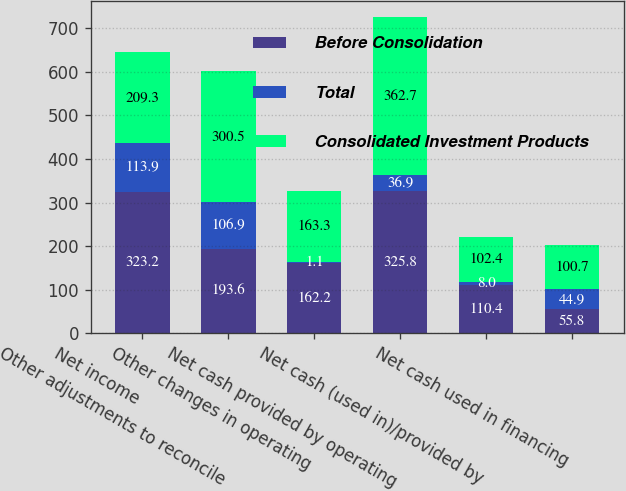Convert chart to OTSL. <chart><loc_0><loc_0><loc_500><loc_500><stacked_bar_chart><ecel><fcel>Net income<fcel>Other adjustments to reconcile<fcel>Other changes in operating<fcel>Net cash provided by operating<fcel>Net cash (used in)/provided by<fcel>Net cash used in financing<nl><fcel>Before Consolidation<fcel>323.2<fcel>193.6<fcel>162.2<fcel>325.8<fcel>110.4<fcel>55.8<nl><fcel>Total<fcel>113.9<fcel>106.9<fcel>1.1<fcel>36.9<fcel>8<fcel>44.9<nl><fcel>Consolidated Investment Products<fcel>209.3<fcel>300.5<fcel>163.3<fcel>362.7<fcel>102.4<fcel>100.7<nl></chart> 